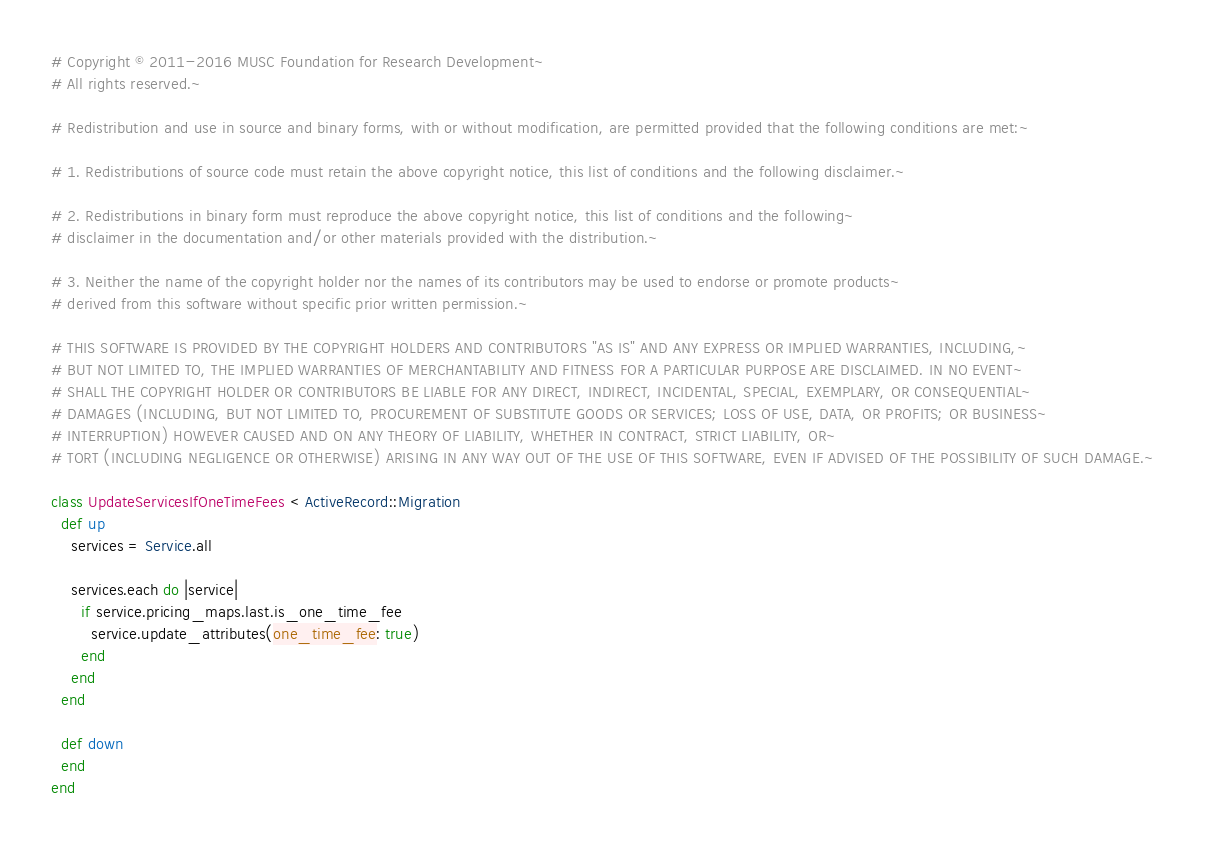<code> <loc_0><loc_0><loc_500><loc_500><_Ruby_># Copyright © 2011-2016 MUSC Foundation for Research Development~
# All rights reserved.~

# Redistribution and use in source and binary forms, with or without modification, are permitted provided that the following conditions are met:~

# 1. Redistributions of source code must retain the above copyright notice, this list of conditions and the following disclaimer.~

# 2. Redistributions in binary form must reproduce the above copyright notice, this list of conditions and the following~
# disclaimer in the documentation and/or other materials provided with the distribution.~

# 3. Neither the name of the copyright holder nor the names of its contributors may be used to endorse or promote products~
# derived from this software without specific prior written permission.~

# THIS SOFTWARE IS PROVIDED BY THE COPYRIGHT HOLDERS AND CONTRIBUTORS "AS IS" AND ANY EXPRESS OR IMPLIED WARRANTIES, INCLUDING,~
# BUT NOT LIMITED TO, THE IMPLIED WARRANTIES OF MERCHANTABILITY AND FITNESS FOR A PARTICULAR PURPOSE ARE DISCLAIMED. IN NO EVENT~
# SHALL THE COPYRIGHT HOLDER OR CONTRIBUTORS BE LIABLE FOR ANY DIRECT, INDIRECT, INCIDENTAL, SPECIAL, EXEMPLARY, OR CONSEQUENTIAL~
# DAMAGES (INCLUDING, BUT NOT LIMITED TO, PROCUREMENT OF SUBSTITUTE GOODS OR SERVICES; LOSS OF USE, DATA, OR PROFITS; OR BUSINESS~
# INTERRUPTION) HOWEVER CAUSED AND ON ANY THEORY OF LIABILITY, WHETHER IN CONTRACT, STRICT LIABILITY, OR~
# TORT (INCLUDING NEGLIGENCE OR OTHERWISE) ARISING IN ANY WAY OUT OF THE USE OF THIS SOFTWARE, EVEN IF ADVISED OF THE POSSIBILITY OF SUCH DAMAGE.~

class UpdateServicesIfOneTimeFees < ActiveRecord::Migration
  def up
    services = Service.all

    services.each do |service|
      if service.pricing_maps.last.is_one_time_fee
        service.update_attributes(one_time_fee: true)
      end
    end
  end

  def down
  end
end
</code> 